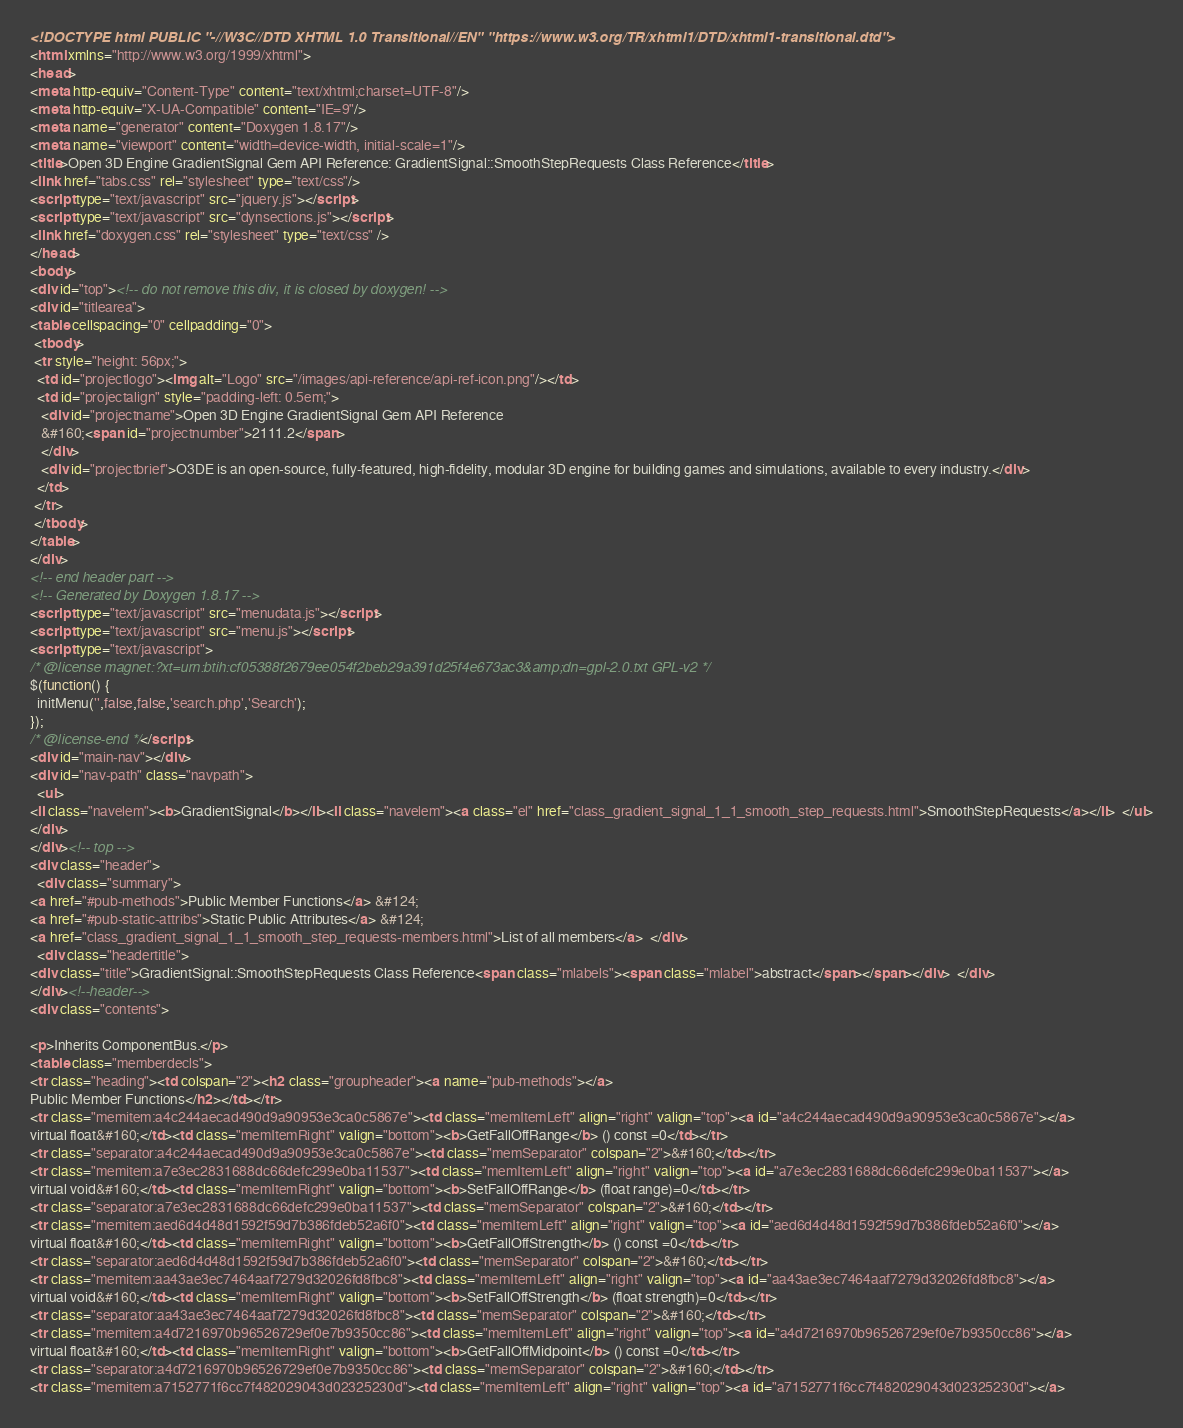<code> <loc_0><loc_0><loc_500><loc_500><_HTML_><!DOCTYPE html PUBLIC "-//W3C//DTD XHTML 1.0 Transitional//EN" "https://www.w3.org/TR/xhtml1/DTD/xhtml1-transitional.dtd">
<html xmlns="http://www.w3.org/1999/xhtml">
<head>
<meta http-equiv="Content-Type" content="text/xhtml;charset=UTF-8"/>
<meta http-equiv="X-UA-Compatible" content="IE=9"/>
<meta name="generator" content="Doxygen 1.8.17"/>
<meta name="viewport" content="width=device-width, initial-scale=1"/>
<title>Open 3D Engine GradientSignal Gem API Reference: GradientSignal::SmoothStepRequests Class Reference</title>
<link href="tabs.css" rel="stylesheet" type="text/css"/>
<script type="text/javascript" src="jquery.js"></script>
<script type="text/javascript" src="dynsections.js"></script>
<link href="doxygen.css" rel="stylesheet" type="text/css" />
</head>
<body>
<div id="top"><!-- do not remove this div, it is closed by doxygen! -->
<div id="titlearea">
<table cellspacing="0" cellpadding="0">
 <tbody>
 <tr style="height: 56px;">
  <td id="projectlogo"><img alt="Logo" src="/images/api-reference/api-ref-icon.png"/></td>
  <td id="projectalign" style="padding-left: 0.5em;">
   <div id="projectname">Open 3D Engine GradientSignal Gem API Reference
   &#160;<span id="projectnumber">2111.2</span>
   </div>
   <div id="projectbrief">O3DE is an open-source, fully-featured, high-fidelity, modular 3D engine for building games and simulations, available to every industry.</div>
  </td>
 </tr>
 </tbody>
</table>
</div>
<!-- end header part -->
<!-- Generated by Doxygen 1.8.17 -->
<script type="text/javascript" src="menudata.js"></script>
<script type="text/javascript" src="menu.js"></script>
<script type="text/javascript">
/* @license magnet:?xt=urn:btih:cf05388f2679ee054f2beb29a391d25f4e673ac3&amp;dn=gpl-2.0.txt GPL-v2 */
$(function() {
  initMenu('',false,false,'search.php','Search');
});
/* @license-end */</script>
<div id="main-nav"></div>
<div id="nav-path" class="navpath">
  <ul>
<li class="navelem"><b>GradientSignal</b></li><li class="navelem"><a class="el" href="class_gradient_signal_1_1_smooth_step_requests.html">SmoothStepRequests</a></li>  </ul>
</div>
</div><!-- top -->
<div class="header">
  <div class="summary">
<a href="#pub-methods">Public Member Functions</a> &#124;
<a href="#pub-static-attribs">Static Public Attributes</a> &#124;
<a href="class_gradient_signal_1_1_smooth_step_requests-members.html">List of all members</a>  </div>
  <div class="headertitle">
<div class="title">GradientSignal::SmoothStepRequests Class Reference<span class="mlabels"><span class="mlabel">abstract</span></span></div>  </div>
</div><!--header-->
<div class="contents">

<p>Inherits ComponentBus.</p>
<table class="memberdecls">
<tr class="heading"><td colspan="2"><h2 class="groupheader"><a name="pub-methods"></a>
Public Member Functions</h2></td></tr>
<tr class="memitem:a4c244aecad490d9a90953e3ca0c5867e"><td class="memItemLeft" align="right" valign="top"><a id="a4c244aecad490d9a90953e3ca0c5867e"></a>
virtual float&#160;</td><td class="memItemRight" valign="bottom"><b>GetFallOffRange</b> () const =0</td></tr>
<tr class="separator:a4c244aecad490d9a90953e3ca0c5867e"><td class="memSeparator" colspan="2">&#160;</td></tr>
<tr class="memitem:a7e3ec2831688dc66defc299e0ba11537"><td class="memItemLeft" align="right" valign="top"><a id="a7e3ec2831688dc66defc299e0ba11537"></a>
virtual void&#160;</td><td class="memItemRight" valign="bottom"><b>SetFallOffRange</b> (float range)=0</td></tr>
<tr class="separator:a7e3ec2831688dc66defc299e0ba11537"><td class="memSeparator" colspan="2">&#160;</td></tr>
<tr class="memitem:aed6d4d48d1592f59d7b386fdeb52a6f0"><td class="memItemLeft" align="right" valign="top"><a id="aed6d4d48d1592f59d7b386fdeb52a6f0"></a>
virtual float&#160;</td><td class="memItemRight" valign="bottom"><b>GetFallOffStrength</b> () const =0</td></tr>
<tr class="separator:aed6d4d48d1592f59d7b386fdeb52a6f0"><td class="memSeparator" colspan="2">&#160;</td></tr>
<tr class="memitem:aa43ae3ec7464aaf7279d32026fd8fbc8"><td class="memItemLeft" align="right" valign="top"><a id="aa43ae3ec7464aaf7279d32026fd8fbc8"></a>
virtual void&#160;</td><td class="memItemRight" valign="bottom"><b>SetFallOffStrength</b> (float strength)=0</td></tr>
<tr class="separator:aa43ae3ec7464aaf7279d32026fd8fbc8"><td class="memSeparator" colspan="2">&#160;</td></tr>
<tr class="memitem:a4d7216970b96526729ef0e7b9350cc86"><td class="memItemLeft" align="right" valign="top"><a id="a4d7216970b96526729ef0e7b9350cc86"></a>
virtual float&#160;</td><td class="memItemRight" valign="bottom"><b>GetFallOffMidpoint</b> () const =0</td></tr>
<tr class="separator:a4d7216970b96526729ef0e7b9350cc86"><td class="memSeparator" colspan="2">&#160;</td></tr>
<tr class="memitem:a7152771f6cc7f482029043d02325230d"><td class="memItemLeft" align="right" valign="top"><a id="a7152771f6cc7f482029043d02325230d"></a></code> 